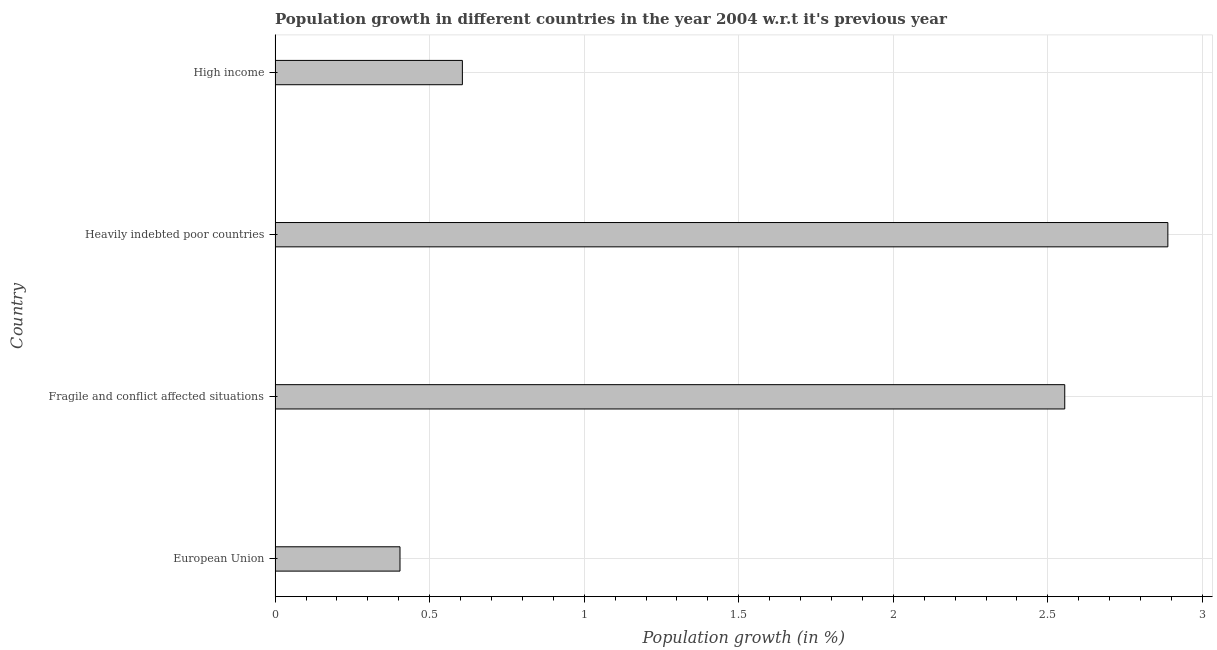What is the title of the graph?
Provide a succinct answer. Population growth in different countries in the year 2004 w.r.t it's previous year. What is the label or title of the X-axis?
Your answer should be compact. Population growth (in %). What is the population growth in High income?
Give a very brief answer. 0.61. Across all countries, what is the maximum population growth?
Keep it short and to the point. 2.89. Across all countries, what is the minimum population growth?
Ensure brevity in your answer.  0.4. In which country was the population growth maximum?
Ensure brevity in your answer.  Heavily indebted poor countries. What is the sum of the population growth?
Provide a short and direct response. 6.45. What is the difference between the population growth in Heavily indebted poor countries and High income?
Your answer should be very brief. 2.28. What is the average population growth per country?
Your response must be concise. 1.61. What is the median population growth?
Your answer should be very brief. 1.58. What is the ratio of the population growth in European Union to that in Heavily indebted poor countries?
Provide a short and direct response. 0.14. Is the population growth in Fragile and conflict affected situations less than that in Heavily indebted poor countries?
Your answer should be very brief. Yes. What is the difference between the highest and the second highest population growth?
Ensure brevity in your answer.  0.33. Is the sum of the population growth in European Union and Fragile and conflict affected situations greater than the maximum population growth across all countries?
Give a very brief answer. Yes. What is the difference between the highest and the lowest population growth?
Give a very brief answer. 2.48. Are all the bars in the graph horizontal?
Make the answer very short. Yes. How many countries are there in the graph?
Keep it short and to the point. 4. What is the difference between two consecutive major ticks on the X-axis?
Your response must be concise. 0.5. Are the values on the major ticks of X-axis written in scientific E-notation?
Your answer should be very brief. No. What is the Population growth (in %) of European Union?
Provide a succinct answer. 0.4. What is the Population growth (in %) in Fragile and conflict affected situations?
Ensure brevity in your answer.  2.55. What is the Population growth (in %) in Heavily indebted poor countries?
Your answer should be very brief. 2.89. What is the Population growth (in %) of High income?
Your answer should be compact. 0.61. What is the difference between the Population growth (in %) in European Union and Fragile and conflict affected situations?
Keep it short and to the point. -2.15. What is the difference between the Population growth (in %) in European Union and Heavily indebted poor countries?
Make the answer very short. -2.48. What is the difference between the Population growth (in %) in European Union and High income?
Your response must be concise. -0.2. What is the difference between the Population growth (in %) in Fragile and conflict affected situations and Heavily indebted poor countries?
Offer a terse response. -0.33. What is the difference between the Population growth (in %) in Fragile and conflict affected situations and High income?
Your response must be concise. 1.95. What is the difference between the Population growth (in %) in Heavily indebted poor countries and High income?
Give a very brief answer. 2.28. What is the ratio of the Population growth (in %) in European Union to that in Fragile and conflict affected situations?
Your answer should be compact. 0.16. What is the ratio of the Population growth (in %) in European Union to that in Heavily indebted poor countries?
Give a very brief answer. 0.14. What is the ratio of the Population growth (in %) in European Union to that in High income?
Your response must be concise. 0.67. What is the ratio of the Population growth (in %) in Fragile and conflict affected situations to that in Heavily indebted poor countries?
Keep it short and to the point. 0.89. What is the ratio of the Population growth (in %) in Fragile and conflict affected situations to that in High income?
Offer a very short reply. 4.22. What is the ratio of the Population growth (in %) in Heavily indebted poor countries to that in High income?
Your response must be concise. 4.77. 